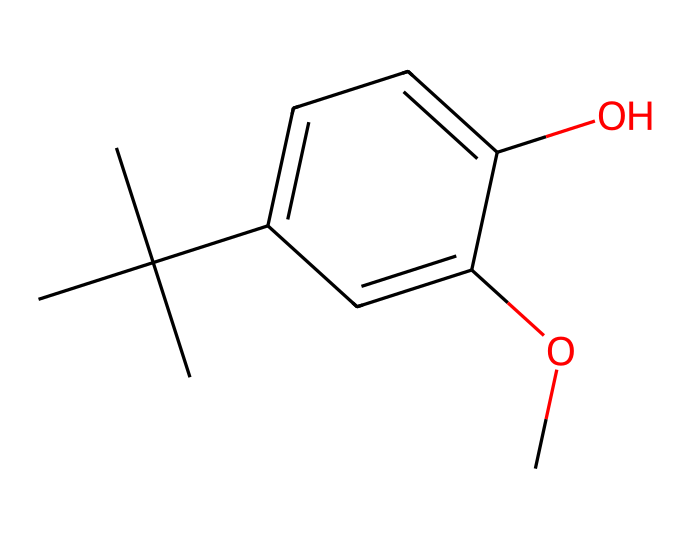What is the molecular formula of butylated hydroxyanisole (BHA)? To determine the molecular formula, we count the number of each type of atom in the SMILES representation. The SMILES shows 10 carbon atoms (C), 14 hydrogen atoms (H), and 3 oxygen atoms (O), leading to the formula C10H14O3.
Answer: C10H14O3 How many hydroxyl groups are present in the structure? A hydroxyl group (-OH) is indicated by the presence of an oxygen atom bonded to a hydrogen atom. In the SMILES, there is one -OH group attached to the aromatic ring, which shows there is one hydroxyl group.
Answer: one What type of preservative is butylated hydroxyanisole (BHA)? BHA is categorized as an antioxidant, which means it works to prevent oxidation in materials. This is indicated by its structure, which has mechanisms to stabilize compounds against oxidative degradation.
Answer: antioxidant What functional group is represented by the "-O-" in the SMILES? The "-O-" indicates a methoxy group (-OCH3), which is a common functional group in phenolic compounds like BHA. It enhances the molecule's antioxidant properties by stabilizing the aromatic ring.
Answer: methoxy group What is the role of BHA in photographic materials? BHA functions as a stabilizer to prevent the oxidation of photographic emulsion components, which can degrade the quality of the photograph. Its structure supports this role due to its antioxidant properties.
Answer: stabilizer How many rings are present in butylated hydroxyanisole (BHA)? Referring to the chemical structure, there is one aromatic ring present in the structure, which is evident from the cyclic carbon atoms in the SMILES representation.
Answer: one 